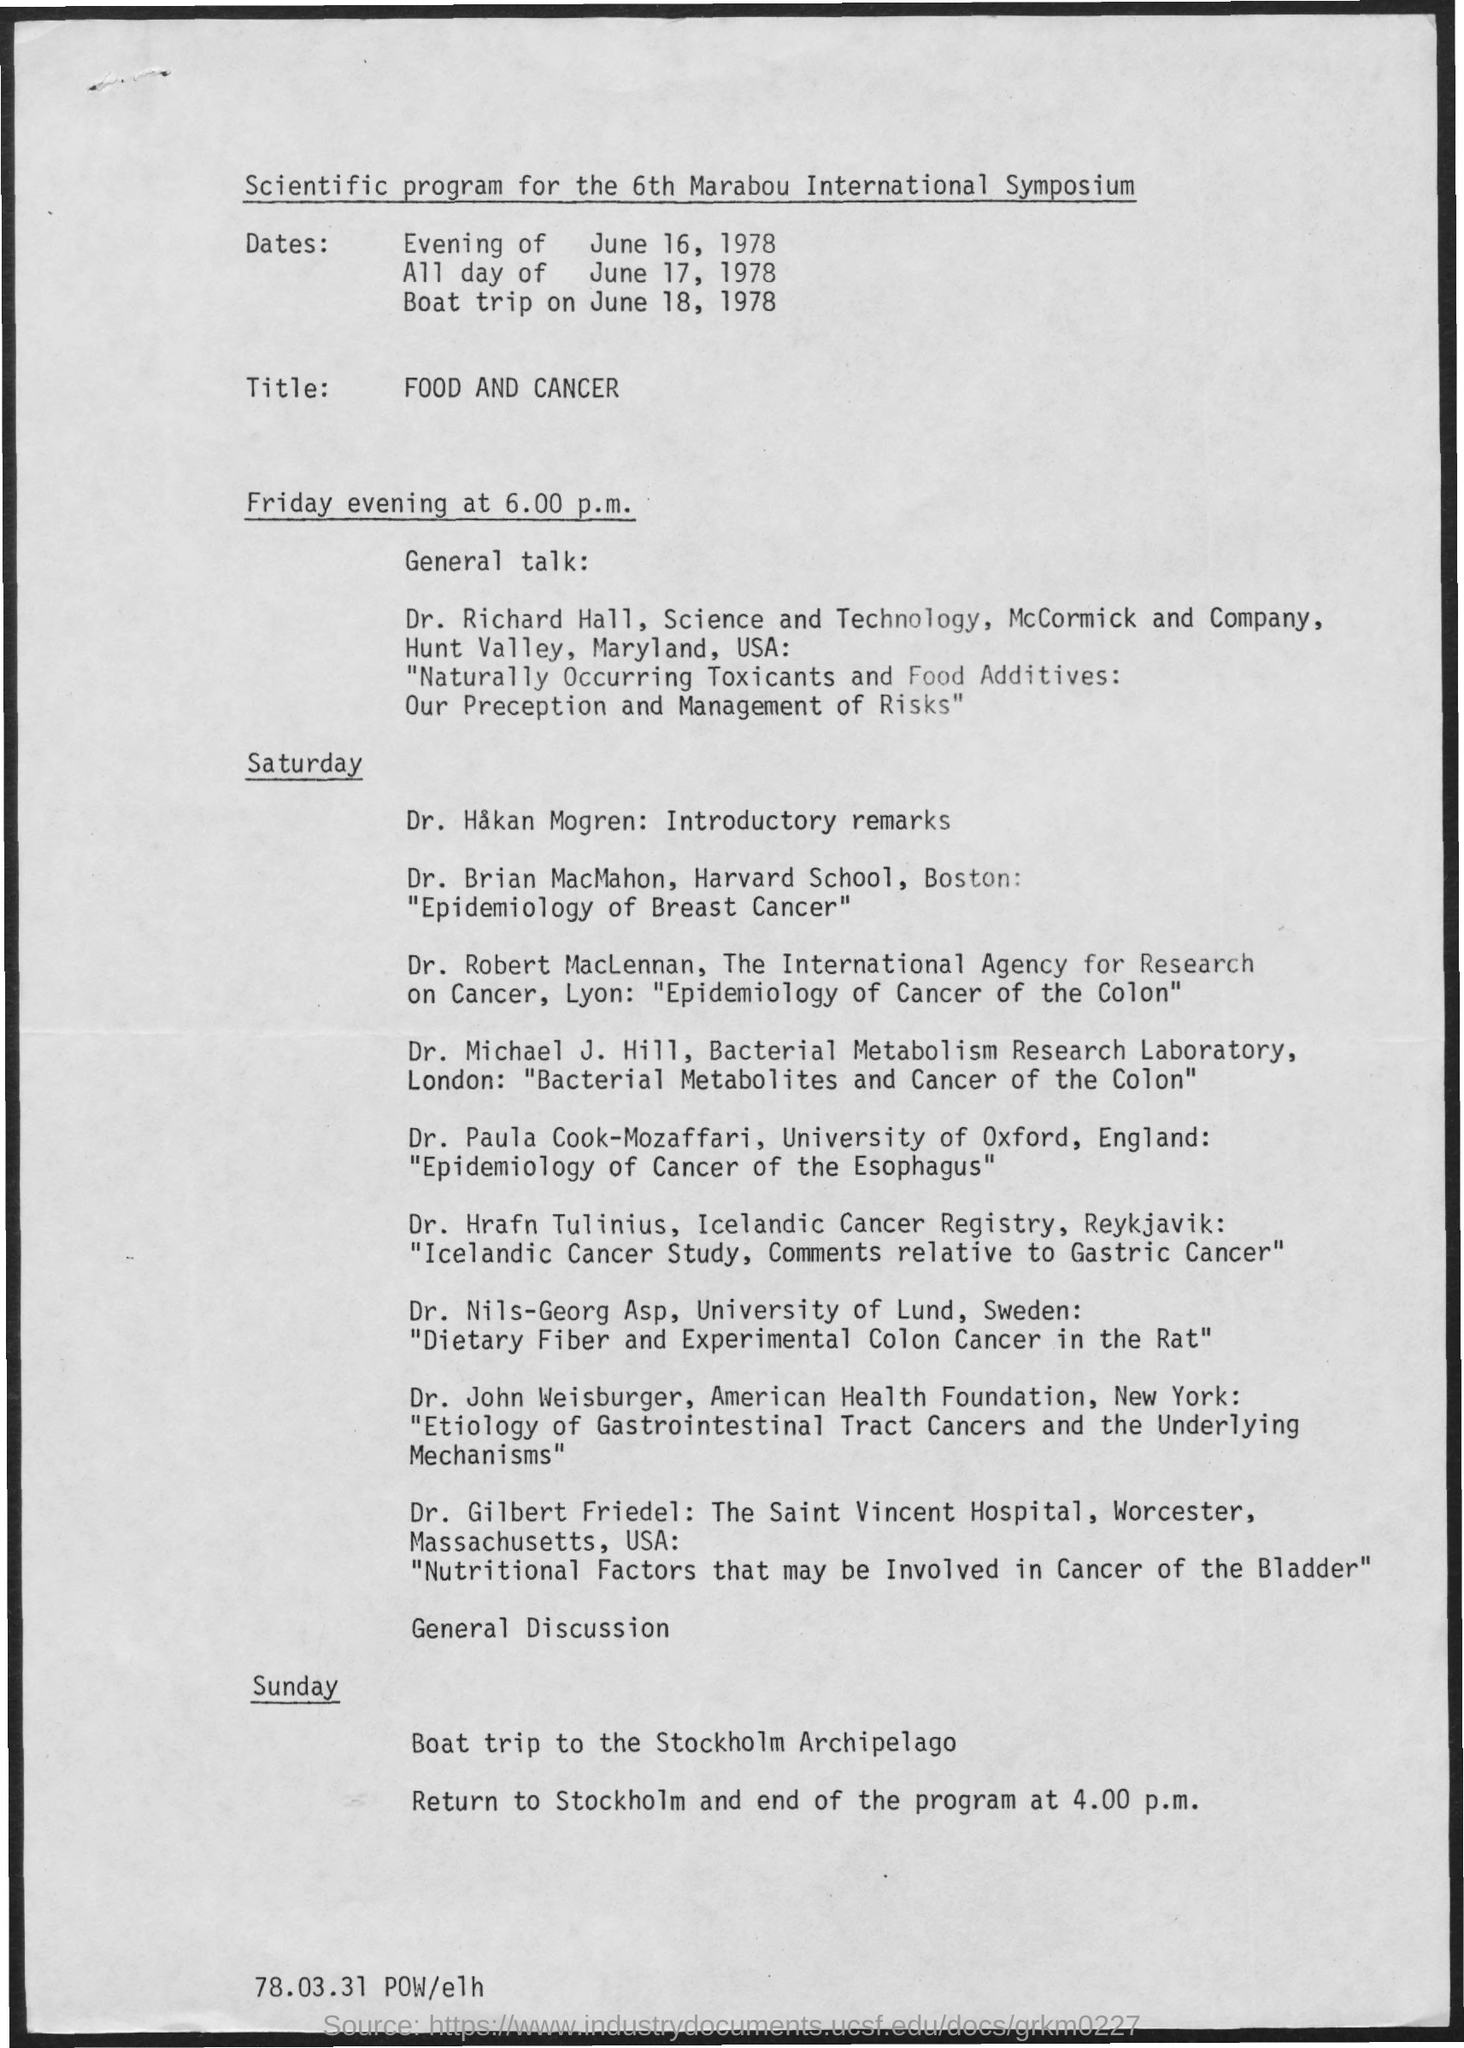Point out several critical features in this image. The boat trip will take place on Sunday. The General Discussion will take place on Saturday. The 6th Marabou International Symposium aims to explore the scientific program's purpose and goals. The general talk will take place on Friday evening. The boat trip is headed to the Stockholm Archipelago. 